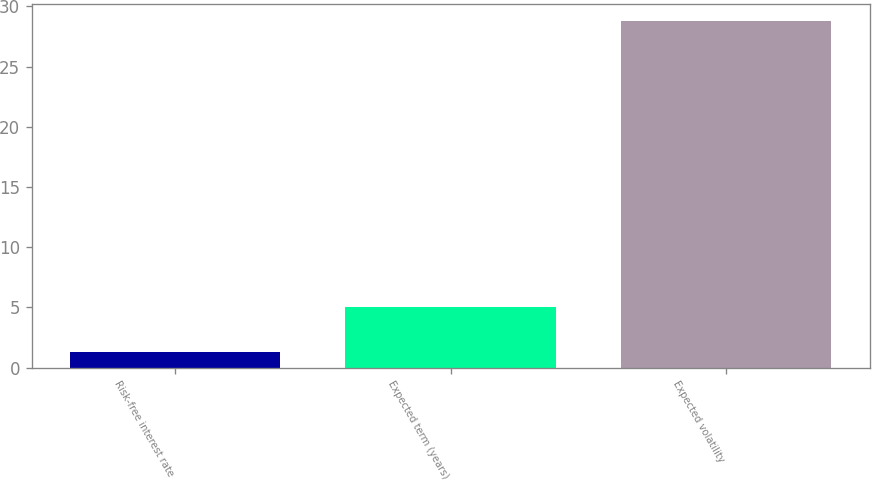Convert chart to OTSL. <chart><loc_0><loc_0><loc_500><loc_500><bar_chart><fcel>Risk-free interest rate<fcel>Expected term (years)<fcel>Expected volatility<nl><fcel>1.26<fcel>5<fcel>28.74<nl></chart> 